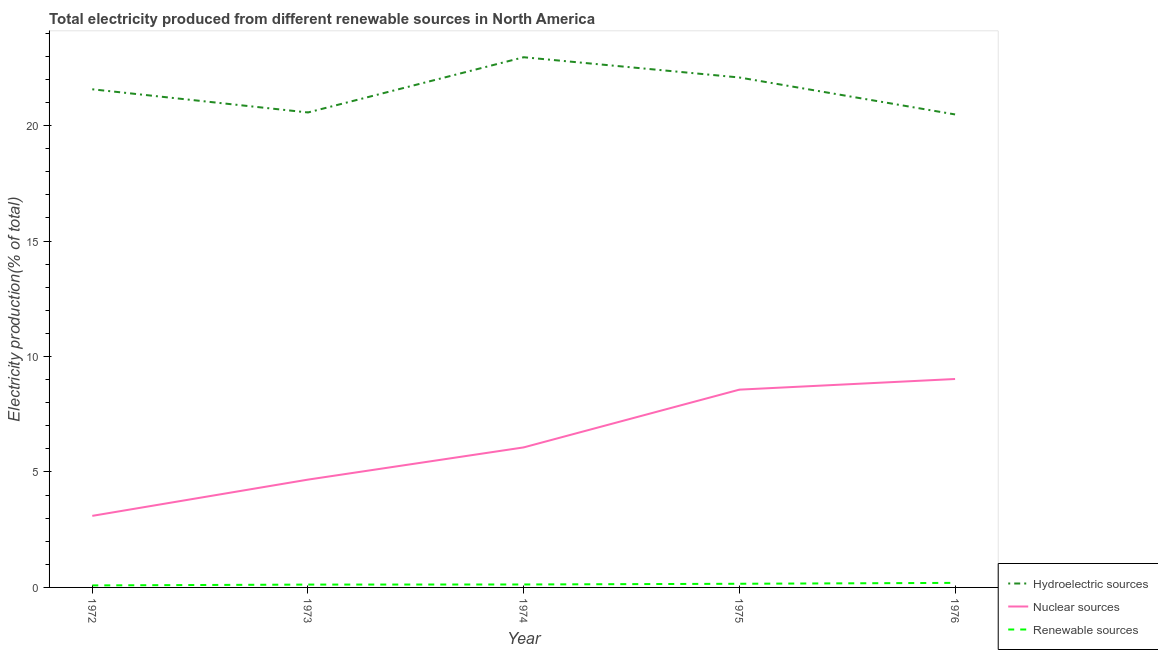How many different coloured lines are there?
Ensure brevity in your answer.  3. Does the line corresponding to percentage of electricity produced by renewable sources intersect with the line corresponding to percentage of electricity produced by hydroelectric sources?
Your answer should be very brief. No. Is the number of lines equal to the number of legend labels?
Ensure brevity in your answer.  Yes. What is the percentage of electricity produced by renewable sources in 1972?
Keep it short and to the point. 0.09. Across all years, what is the maximum percentage of electricity produced by hydroelectric sources?
Provide a short and direct response. 22.96. Across all years, what is the minimum percentage of electricity produced by renewable sources?
Give a very brief answer. 0.09. In which year was the percentage of electricity produced by nuclear sources maximum?
Your answer should be very brief. 1976. In which year was the percentage of electricity produced by hydroelectric sources minimum?
Make the answer very short. 1976. What is the total percentage of electricity produced by nuclear sources in the graph?
Ensure brevity in your answer.  31.42. What is the difference between the percentage of electricity produced by hydroelectric sources in 1975 and that in 1976?
Your answer should be compact. 1.6. What is the difference between the percentage of electricity produced by renewable sources in 1973 and the percentage of electricity produced by hydroelectric sources in 1976?
Keep it short and to the point. -20.36. What is the average percentage of electricity produced by hydroelectric sources per year?
Your answer should be very brief. 21.53. In the year 1972, what is the difference between the percentage of electricity produced by renewable sources and percentage of electricity produced by hydroelectric sources?
Your answer should be compact. -21.49. In how many years, is the percentage of electricity produced by nuclear sources greater than 20 %?
Your response must be concise. 0. What is the ratio of the percentage of electricity produced by hydroelectric sources in 1972 to that in 1975?
Offer a terse response. 0.98. What is the difference between the highest and the second highest percentage of electricity produced by nuclear sources?
Your response must be concise. 0.46. What is the difference between the highest and the lowest percentage of electricity produced by renewable sources?
Make the answer very short. 0.11. In how many years, is the percentage of electricity produced by hydroelectric sources greater than the average percentage of electricity produced by hydroelectric sources taken over all years?
Offer a very short reply. 3. Is the sum of the percentage of electricity produced by hydroelectric sources in 1973 and 1975 greater than the maximum percentage of electricity produced by renewable sources across all years?
Your answer should be very brief. Yes. Is it the case that in every year, the sum of the percentage of electricity produced by hydroelectric sources and percentage of electricity produced by nuclear sources is greater than the percentage of electricity produced by renewable sources?
Make the answer very short. Yes. Is the percentage of electricity produced by hydroelectric sources strictly greater than the percentage of electricity produced by renewable sources over the years?
Offer a very short reply. Yes. Is the percentage of electricity produced by nuclear sources strictly less than the percentage of electricity produced by renewable sources over the years?
Offer a terse response. No. How many lines are there?
Your response must be concise. 3. Are the values on the major ticks of Y-axis written in scientific E-notation?
Ensure brevity in your answer.  No. Does the graph contain any zero values?
Give a very brief answer. No. Does the graph contain grids?
Provide a succinct answer. No. Where does the legend appear in the graph?
Provide a succinct answer. Bottom right. What is the title of the graph?
Your answer should be compact. Total electricity produced from different renewable sources in North America. Does "Transport services" appear as one of the legend labels in the graph?
Provide a short and direct response. No. What is the Electricity production(% of total) in Hydroelectric sources in 1972?
Ensure brevity in your answer.  21.57. What is the Electricity production(% of total) in Nuclear sources in 1972?
Keep it short and to the point. 3.1. What is the Electricity production(% of total) of Renewable sources in 1972?
Provide a succinct answer. 0.09. What is the Electricity production(% of total) of Hydroelectric sources in 1973?
Provide a succinct answer. 20.57. What is the Electricity production(% of total) in Nuclear sources in 1973?
Offer a very short reply. 4.67. What is the Electricity production(% of total) in Renewable sources in 1973?
Your response must be concise. 0.12. What is the Electricity production(% of total) in Hydroelectric sources in 1974?
Your response must be concise. 22.96. What is the Electricity production(% of total) of Nuclear sources in 1974?
Keep it short and to the point. 6.06. What is the Electricity production(% of total) of Renewable sources in 1974?
Your answer should be very brief. 0.13. What is the Electricity production(% of total) in Hydroelectric sources in 1975?
Offer a terse response. 22.08. What is the Electricity production(% of total) in Nuclear sources in 1975?
Your answer should be very brief. 8.57. What is the Electricity production(% of total) in Renewable sources in 1975?
Give a very brief answer. 0.16. What is the Electricity production(% of total) of Hydroelectric sources in 1976?
Keep it short and to the point. 20.48. What is the Electricity production(% of total) in Nuclear sources in 1976?
Keep it short and to the point. 9.03. What is the Electricity production(% of total) in Renewable sources in 1976?
Your response must be concise. 0.2. Across all years, what is the maximum Electricity production(% of total) in Hydroelectric sources?
Provide a succinct answer. 22.96. Across all years, what is the maximum Electricity production(% of total) in Nuclear sources?
Provide a short and direct response. 9.03. Across all years, what is the maximum Electricity production(% of total) in Renewable sources?
Provide a succinct answer. 0.2. Across all years, what is the minimum Electricity production(% of total) of Hydroelectric sources?
Offer a terse response. 20.48. Across all years, what is the minimum Electricity production(% of total) in Nuclear sources?
Provide a succinct answer. 3.1. Across all years, what is the minimum Electricity production(% of total) of Renewable sources?
Your response must be concise. 0.09. What is the total Electricity production(% of total) in Hydroelectric sources in the graph?
Your answer should be compact. 107.67. What is the total Electricity production(% of total) in Nuclear sources in the graph?
Ensure brevity in your answer.  31.42. What is the total Electricity production(% of total) of Renewable sources in the graph?
Provide a short and direct response. 0.69. What is the difference between the Electricity production(% of total) of Hydroelectric sources in 1972 and that in 1973?
Provide a succinct answer. 1. What is the difference between the Electricity production(% of total) in Nuclear sources in 1972 and that in 1973?
Your response must be concise. -1.57. What is the difference between the Electricity production(% of total) of Renewable sources in 1972 and that in 1973?
Provide a succinct answer. -0.04. What is the difference between the Electricity production(% of total) in Hydroelectric sources in 1972 and that in 1974?
Give a very brief answer. -1.39. What is the difference between the Electricity production(% of total) of Nuclear sources in 1972 and that in 1974?
Provide a short and direct response. -2.97. What is the difference between the Electricity production(% of total) of Renewable sources in 1972 and that in 1974?
Offer a very short reply. -0.04. What is the difference between the Electricity production(% of total) of Hydroelectric sources in 1972 and that in 1975?
Give a very brief answer. -0.51. What is the difference between the Electricity production(% of total) in Nuclear sources in 1972 and that in 1975?
Make the answer very short. -5.47. What is the difference between the Electricity production(% of total) of Renewable sources in 1972 and that in 1975?
Your answer should be compact. -0.07. What is the difference between the Electricity production(% of total) in Hydroelectric sources in 1972 and that in 1976?
Give a very brief answer. 1.09. What is the difference between the Electricity production(% of total) of Nuclear sources in 1972 and that in 1976?
Your response must be concise. -5.93. What is the difference between the Electricity production(% of total) in Renewable sources in 1972 and that in 1976?
Make the answer very short. -0.11. What is the difference between the Electricity production(% of total) of Hydroelectric sources in 1973 and that in 1974?
Provide a succinct answer. -2.39. What is the difference between the Electricity production(% of total) of Nuclear sources in 1973 and that in 1974?
Offer a very short reply. -1.4. What is the difference between the Electricity production(% of total) of Renewable sources in 1973 and that in 1974?
Ensure brevity in your answer.  -0. What is the difference between the Electricity production(% of total) of Hydroelectric sources in 1973 and that in 1975?
Keep it short and to the point. -1.51. What is the difference between the Electricity production(% of total) of Nuclear sources in 1973 and that in 1975?
Ensure brevity in your answer.  -3.9. What is the difference between the Electricity production(% of total) of Renewable sources in 1973 and that in 1975?
Provide a short and direct response. -0.04. What is the difference between the Electricity production(% of total) in Hydroelectric sources in 1973 and that in 1976?
Give a very brief answer. 0.09. What is the difference between the Electricity production(% of total) of Nuclear sources in 1973 and that in 1976?
Your response must be concise. -4.36. What is the difference between the Electricity production(% of total) of Renewable sources in 1973 and that in 1976?
Your answer should be compact. -0.07. What is the difference between the Electricity production(% of total) of Hydroelectric sources in 1974 and that in 1975?
Provide a succinct answer. 0.88. What is the difference between the Electricity production(% of total) of Nuclear sources in 1974 and that in 1975?
Provide a short and direct response. -2.5. What is the difference between the Electricity production(% of total) in Renewable sources in 1974 and that in 1975?
Make the answer very short. -0.03. What is the difference between the Electricity production(% of total) in Hydroelectric sources in 1974 and that in 1976?
Your answer should be very brief. 2.48. What is the difference between the Electricity production(% of total) of Nuclear sources in 1974 and that in 1976?
Offer a very short reply. -2.96. What is the difference between the Electricity production(% of total) in Renewable sources in 1974 and that in 1976?
Offer a terse response. -0.07. What is the difference between the Electricity production(% of total) in Hydroelectric sources in 1975 and that in 1976?
Ensure brevity in your answer.  1.6. What is the difference between the Electricity production(% of total) of Nuclear sources in 1975 and that in 1976?
Keep it short and to the point. -0.46. What is the difference between the Electricity production(% of total) in Renewable sources in 1975 and that in 1976?
Your answer should be very brief. -0.04. What is the difference between the Electricity production(% of total) of Hydroelectric sources in 1972 and the Electricity production(% of total) of Nuclear sources in 1973?
Provide a short and direct response. 16.9. What is the difference between the Electricity production(% of total) in Hydroelectric sources in 1972 and the Electricity production(% of total) in Renewable sources in 1973?
Your answer should be very brief. 21.45. What is the difference between the Electricity production(% of total) in Nuclear sources in 1972 and the Electricity production(% of total) in Renewable sources in 1973?
Keep it short and to the point. 2.98. What is the difference between the Electricity production(% of total) of Hydroelectric sources in 1972 and the Electricity production(% of total) of Nuclear sources in 1974?
Your answer should be very brief. 15.51. What is the difference between the Electricity production(% of total) of Hydroelectric sources in 1972 and the Electricity production(% of total) of Renewable sources in 1974?
Offer a very short reply. 21.45. What is the difference between the Electricity production(% of total) of Nuclear sources in 1972 and the Electricity production(% of total) of Renewable sources in 1974?
Provide a succinct answer. 2.97. What is the difference between the Electricity production(% of total) in Hydroelectric sources in 1972 and the Electricity production(% of total) in Nuclear sources in 1975?
Offer a terse response. 13.01. What is the difference between the Electricity production(% of total) of Hydroelectric sources in 1972 and the Electricity production(% of total) of Renewable sources in 1975?
Make the answer very short. 21.41. What is the difference between the Electricity production(% of total) of Nuclear sources in 1972 and the Electricity production(% of total) of Renewable sources in 1975?
Your answer should be very brief. 2.94. What is the difference between the Electricity production(% of total) in Hydroelectric sources in 1972 and the Electricity production(% of total) in Nuclear sources in 1976?
Offer a terse response. 12.55. What is the difference between the Electricity production(% of total) in Hydroelectric sources in 1972 and the Electricity production(% of total) in Renewable sources in 1976?
Give a very brief answer. 21.38. What is the difference between the Electricity production(% of total) of Nuclear sources in 1972 and the Electricity production(% of total) of Renewable sources in 1976?
Provide a short and direct response. 2.9. What is the difference between the Electricity production(% of total) of Hydroelectric sources in 1973 and the Electricity production(% of total) of Nuclear sources in 1974?
Give a very brief answer. 14.51. What is the difference between the Electricity production(% of total) in Hydroelectric sources in 1973 and the Electricity production(% of total) in Renewable sources in 1974?
Ensure brevity in your answer.  20.44. What is the difference between the Electricity production(% of total) in Nuclear sources in 1973 and the Electricity production(% of total) in Renewable sources in 1974?
Your response must be concise. 4.54. What is the difference between the Electricity production(% of total) in Hydroelectric sources in 1973 and the Electricity production(% of total) in Nuclear sources in 1975?
Offer a very short reply. 12. What is the difference between the Electricity production(% of total) in Hydroelectric sources in 1973 and the Electricity production(% of total) in Renewable sources in 1975?
Make the answer very short. 20.41. What is the difference between the Electricity production(% of total) in Nuclear sources in 1973 and the Electricity production(% of total) in Renewable sources in 1975?
Keep it short and to the point. 4.51. What is the difference between the Electricity production(% of total) in Hydroelectric sources in 1973 and the Electricity production(% of total) in Nuclear sources in 1976?
Provide a short and direct response. 11.54. What is the difference between the Electricity production(% of total) in Hydroelectric sources in 1973 and the Electricity production(% of total) in Renewable sources in 1976?
Keep it short and to the point. 20.37. What is the difference between the Electricity production(% of total) of Nuclear sources in 1973 and the Electricity production(% of total) of Renewable sources in 1976?
Your answer should be very brief. 4.47. What is the difference between the Electricity production(% of total) in Hydroelectric sources in 1974 and the Electricity production(% of total) in Nuclear sources in 1975?
Your answer should be compact. 14.4. What is the difference between the Electricity production(% of total) of Hydroelectric sources in 1974 and the Electricity production(% of total) of Renewable sources in 1975?
Offer a very short reply. 22.8. What is the difference between the Electricity production(% of total) in Nuclear sources in 1974 and the Electricity production(% of total) in Renewable sources in 1975?
Provide a succinct answer. 5.91. What is the difference between the Electricity production(% of total) in Hydroelectric sources in 1974 and the Electricity production(% of total) in Nuclear sources in 1976?
Provide a succinct answer. 13.93. What is the difference between the Electricity production(% of total) of Hydroelectric sources in 1974 and the Electricity production(% of total) of Renewable sources in 1976?
Offer a terse response. 22.76. What is the difference between the Electricity production(% of total) of Nuclear sources in 1974 and the Electricity production(% of total) of Renewable sources in 1976?
Your answer should be compact. 5.87. What is the difference between the Electricity production(% of total) of Hydroelectric sources in 1975 and the Electricity production(% of total) of Nuclear sources in 1976?
Your answer should be very brief. 13.06. What is the difference between the Electricity production(% of total) in Hydroelectric sources in 1975 and the Electricity production(% of total) in Renewable sources in 1976?
Offer a terse response. 21.89. What is the difference between the Electricity production(% of total) in Nuclear sources in 1975 and the Electricity production(% of total) in Renewable sources in 1976?
Provide a succinct answer. 8.37. What is the average Electricity production(% of total) of Hydroelectric sources per year?
Give a very brief answer. 21.53. What is the average Electricity production(% of total) in Nuclear sources per year?
Offer a very short reply. 6.28. What is the average Electricity production(% of total) of Renewable sources per year?
Provide a succinct answer. 0.14. In the year 1972, what is the difference between the Electricity production(% of total) of Hydroelectric sources and Electricity production(% of total) of Nuclear sources?
Your response must be concise. 18.47. In the year 1972, what is the difference between the Electricity production(% of total) of Hydroelectric sources and Electricity production(% of total) of Renewable sources?
Make the answer very short. 21.49. In the year 1972, what is the difference between the Electricity production(% of total) in Nuclear sources and Electricity production(% of total) in Renewable sources?
Provide a short and direct response. 3.01. In the year 1973, what is the difference between the Electricity production(% of total) in Hydroelectric sources and Electricity production(% of total) in Nuclear sources?
Your answer should be compact. 15.9. In the year 1973, what is the difference between the Electricity production(% of total) of Hydroelectric sources and Electricity production(% of total) of Renewable sources?
Provide a succinct answer. 20.45. In the year 1973, what is the difference between the Electricity production(% of total) in Nuclear sources and Electricity production(% of total) in Renewable sources?
Give a very brief answer. 4.55. In the year 1974, what is the difference between the Electricity production(% of total) in Hydroelectric sources and Electricity production(% of total) in Nuclear sources?
Your answer should be compact. 16.9. In the year 1974, what is the difference between the Electricity production(% of total) in Hydroelectric sources and Electricity production(% of total) in Renewable sources?
Ensure brevity in your answer.  22.83. In the year 1974, what is the difference between the Electricity production(% of total) in Nuclear sources and Electricity production(% of total) in Renewable sources?
Provide a succinct answer. 5.94. In the year 1975, what is the difference between the Electricity production(% of total) in Hydroelectric sources and Electricity production(% of total) in Nuclear sources?
Ensure brevity in your answer.  13.52. In the year 1975, what is the difference between the Electricity production(% of total) of Hydroelectric sources and Electricity production(% of total) of Renewable sources?
Your answer should be very brief. 21.93. In the year 1975, what is the difference between the Electricity production(% of total) of Nuclear sources and Electricity production(% of total) of Renewable sources?
Your answer should be compact. 8.41. In the year 1976, what is the difference between the Electricity production(% of total) in Hydroelectric sources and Electricity production(% of total) in Nuclear sources?
Keep it short and to the point. 11.46. In the year 1976, what is the difference between the Electricity production(% of total) in Hydroelectric sources and Electricity production(% of total) in Renewable sources?
Ensure brevity in your answer.  20.29. In the year 1976, what is the difference between the Electricity production(% of total) of Nuclear sources and Electricity production(% of total) of Renewable sources?
Make the answer very short. 8.83. What is the ratio of the Electricity production(% of total) in Hydroelectric sources in 1972 to that in 1973?
Provide a short and direct response. 1.05. What is the ratio of the Electricity production(% of total) of Nuclear sources in 1972 to that in 1973?
Make the answer very short. 0.66. What is the ratio of the Electricity production(% of total) in Renewable sources in 1972 to that in 1973?
Your answer should be compact. 0.71. What is the ratio of the Electricity production(% of total) in Hydroelectric sources in 1972 to that in 1974?
Offer a terse response. 0.94. What is the ratio of the Electricity production(% of total) in Nuclear sources in 1972 to that in 1974?
Keep it short and to the point. 0.51. What is the ratio of the Electricity production(% of total) of Renewable sources in 1972 to that in 1974?
Offer a terse response. 0.69. What is the ratio of the Electricity production(% of total) of Hydroelectric sources in 1972 to that in 1975?
Keep it short and to the point. 0.98. What is the ratio of the Electricity production(% of total) of Nuclear sources in 1972 to that in 1975?
Offer a very short reply. 0.36. What is the ratio of the Electricity production(% of total) in Renewable sources in 1972 to that in 1975?
Ensure brevity in your answer.  0.55. What is the ratio of the Electricity production(% of total) in Hydroelectric sources in 1972 to that in 1976?
Provide a succinct answer. 1.05. What is the ratio of the Electricity production(% of total) of Nuclear sources in 1972 to that in 1976?
Make the answer very short. 0.34. What is the ratio of the Electricity production(% of total) of Renewable sources in 1972 to that in 1976?
Offer a very short reply. 0.44. What is the ratio of the Electricity production(% of total) of Hydroelectric sources in 1973 to that in 1974?
Give a very brief answer. 0.9. What is the ratio of the Electricity production(% of total) of Nuclear sources in 1973 to that in 1974?
Your answer should be compact. 0.77. What is the ratio of the Electricity production(% of total) in Renewable sources in 1973 to that in 1974?
Your answer should be very brief. 0.96. What is the ratio of the Electricity production(% of total) in Hydroelectric sources in 1973 to that in 1975?
Offer a terse response. 0.93. What is the ratio of the Electricity production(% of total) in Nuclear sources in 1973 to that in 1975?
Offer a very short reply. 0.55. What is the ratio of the Electricity production(% of total) of Renewable sources in 1973 to that in 1975?
Ensure brevity in your answer.  0.78. What is the ratio of the Electricity production(% of total) in Nuclear sources in 1973 to that in 1976?
Offer a terse response. 0.52. What is the ratio of the Electricity production(% of total) of Renewable sources in 1973 to that in 1976?
Your answer should be compact. 0.62. What is the ratio of the Electricity production(% of total) in Hydroelectric sources in 1974 to that in 1975?
Offer a very short reply. 1.04. What is the ratio of the Electricity production(% of total) of Nuclear sources in 1974 to that in 1975?
Ensure brevity in your answer.  0.71. What is the ratio of the Electricity production(% of total) in Renewable sources in 1974 to that in 1975?
Offer a very short reply. 0.81. What is the ratio of the Electricity production(% of total) of Hydroelectric sources in 1974 to that in 1976?
Provide a short and direct response. 1.12. What is the ratio of the Electricity production(% of total) in Nuclear sources in 1974 to that in 1976?
Offer a terse response. 0.67. What is the ratio of the Electricity production(% of total) in Renewable sources in 1974 to that in 1976?
Make the answer very short. 0.65. What is the ratio of the Electricity production(% of total) of Hydroelectric sources in 1975 to that in 1976?
Provide a short and direct response. 1.08. What is the ratio of the Electricity production(% of total) in Nuclear sources in 1975 to that in 1976?
Provide a short and direct response. 0.95. What is the ratio of the Electricity production(% of total) in Renewable sources in 1975 to that in 1976?
Offer a very short reply. 0.8. What is the difference between the highest and the second highest Electricity production(% of total) of Hydroelectric sources?
Your answer should be very brief. 0.88. What is the difference between the highest and the second highest Electricity production(% of total) in Nuclear sources?
Make the answer very short. 0.46. What is the difference between the highest and the second highest Electricity production(% of total) in Renewable sources?
Your answer should be very brief. 0.04. What is the difference between the highest and the lowest Electricity production(% of total) of Hydroelectric sources?
Your response must be concise. 2.48. What is the difference between the highest and the lowest Electricity production(% of total) in Nuclear sources?
Your response must be concise. 5.93. What is the difference between the highest and the lowest Electricity production(% of total) of Renewable sources?
Your answer should be compact. 0.11. 